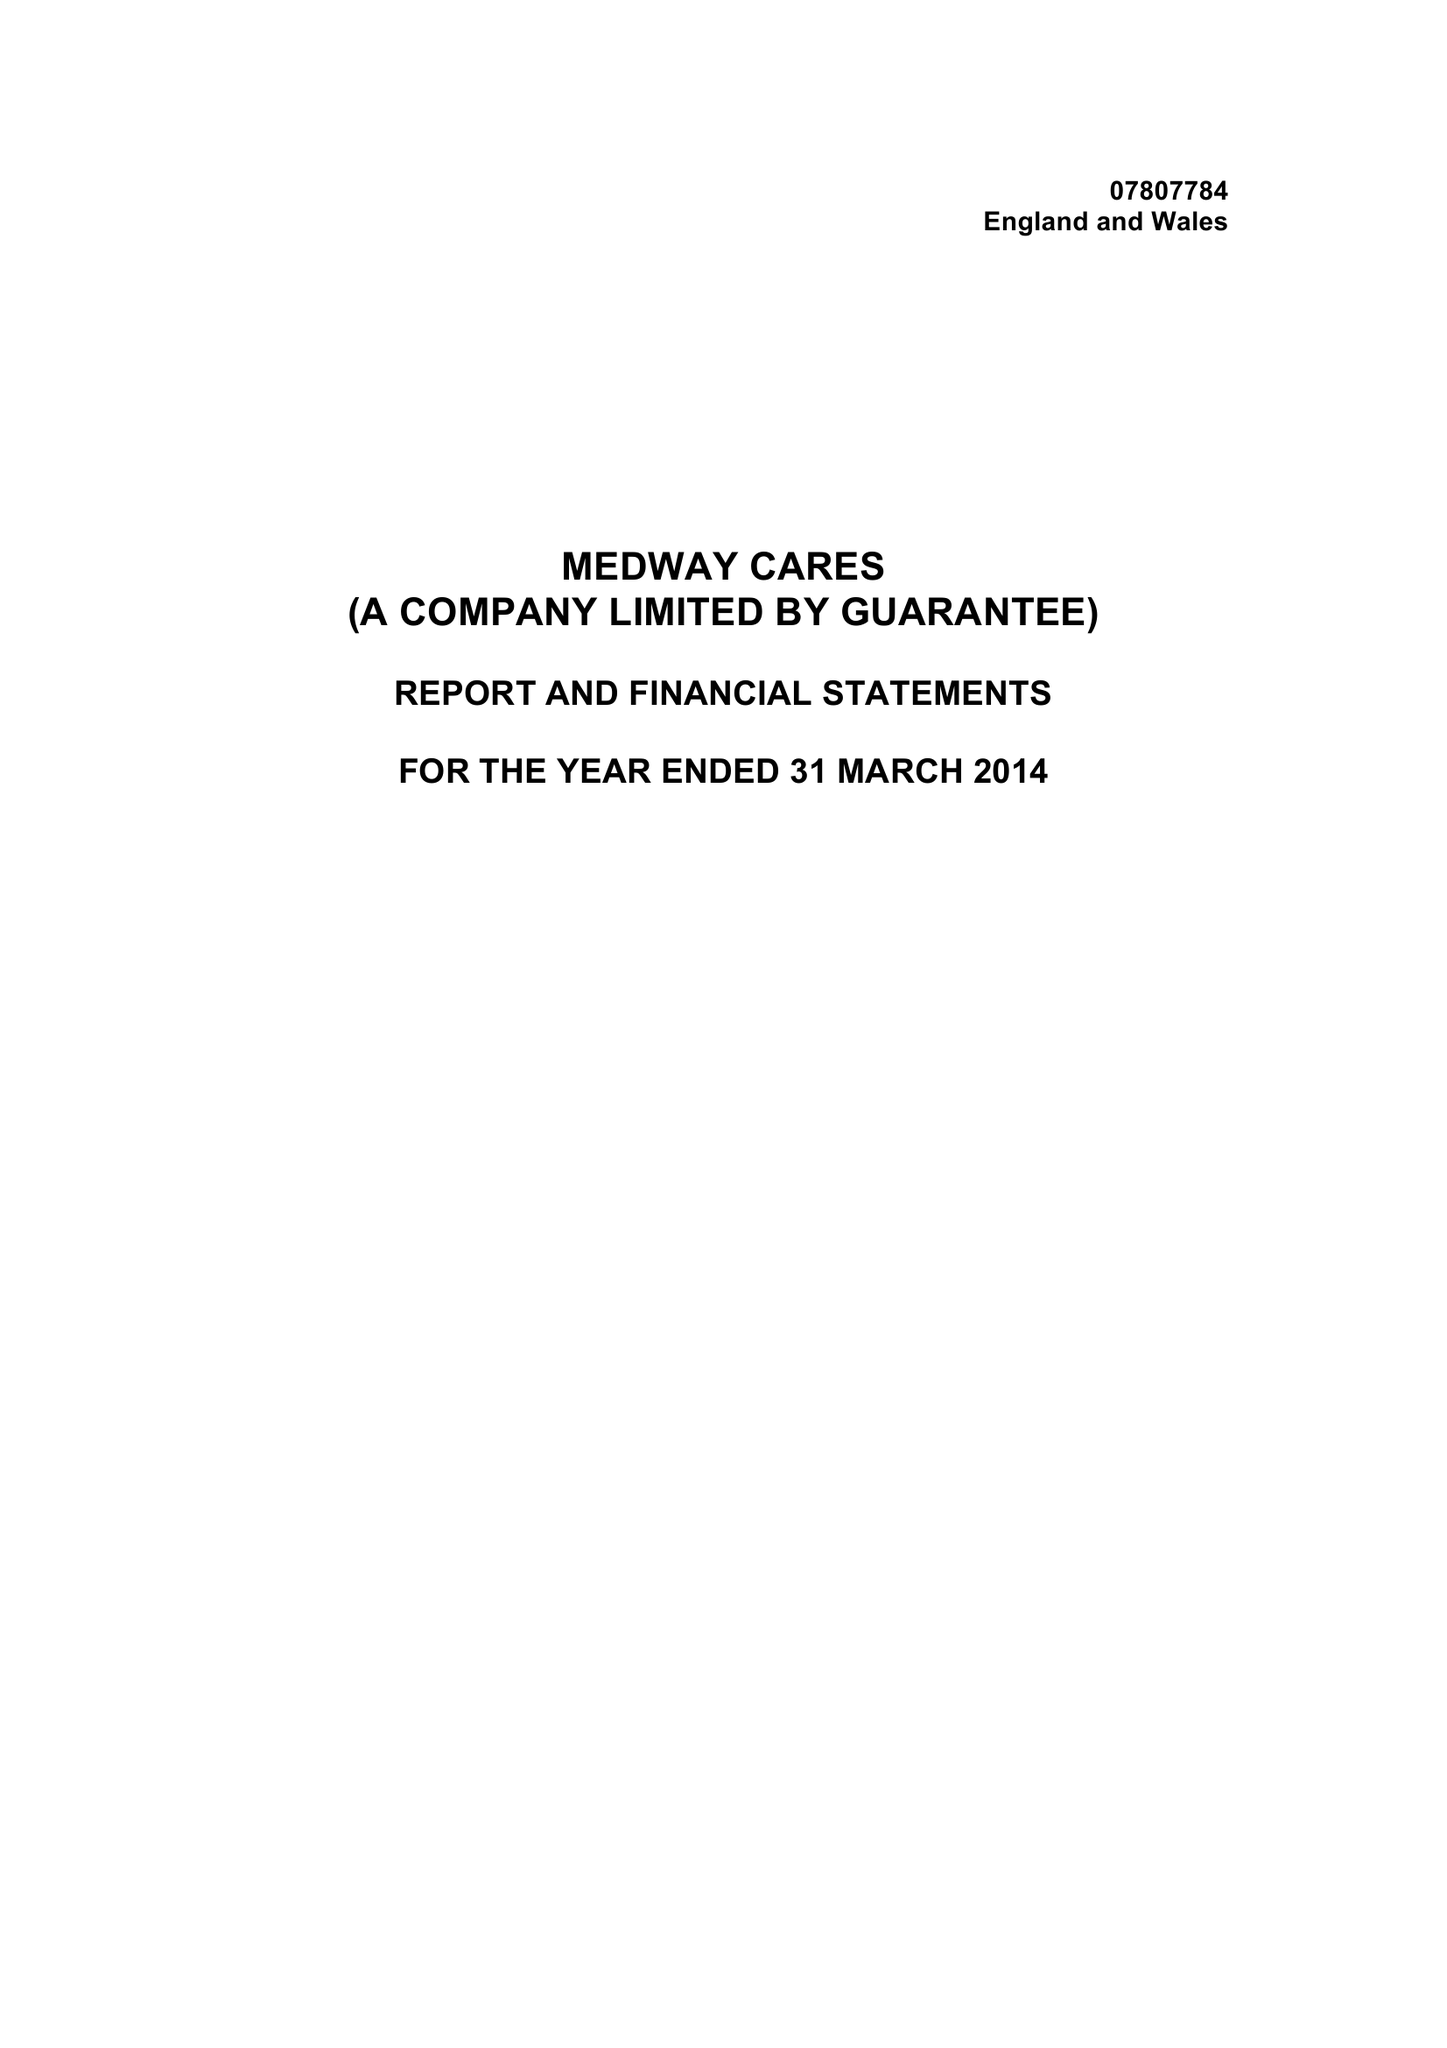What is the value for the income_annually_in_british_pounds?
Answer the question using a single word or phrase. 66578.00 